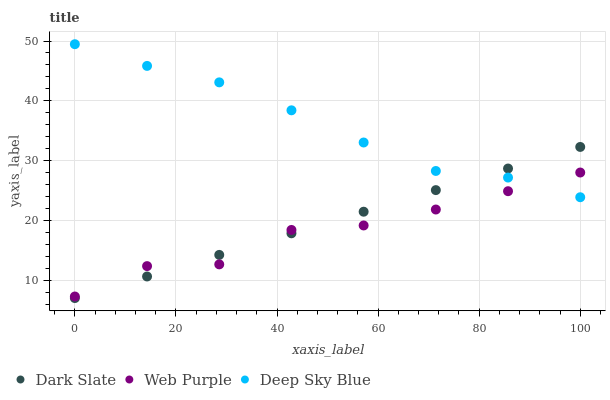Does Web Purple have the minimum area under the curve?
Answer yes or no. Yes. Does Deep Sky Blue have the maximum area under the curve?
Answer yes or no. Yes. Does Deep Sky Blue have the minimum area under the curve?
Answer yes or no. No. Does Web Purple have the maximum area under the curve?
Answer yes or no. No. Is Dark Slate the smoothest?
Answer yes or no. Yes. Is Web Purple the roughest?
Answer yes or no. Yes. Is Deep Sky Blue the smoothest?
Answer yes or no. No. Is Deep Sky Blue the roughest?
Answer yes or no. No. Does Dark Slate have the lowest value?
Answer yes or no. Yes. Does Web Purple have the lowest value?
Answer yes or no. No. Does Deep Sky Blue have the highest value?
Answer yes or no. Yes. Does Web Purple have the highest value?
Answer yes or no. No. Does Deep Sky Blue intersect Web Purple?
Answer yes or no. Yes. Is Deep Sky Blue less than Web Purple?
Answer yes or no. No. Is Deep Sky Blue greater than Web Purple?
Answer yes or no. No. 